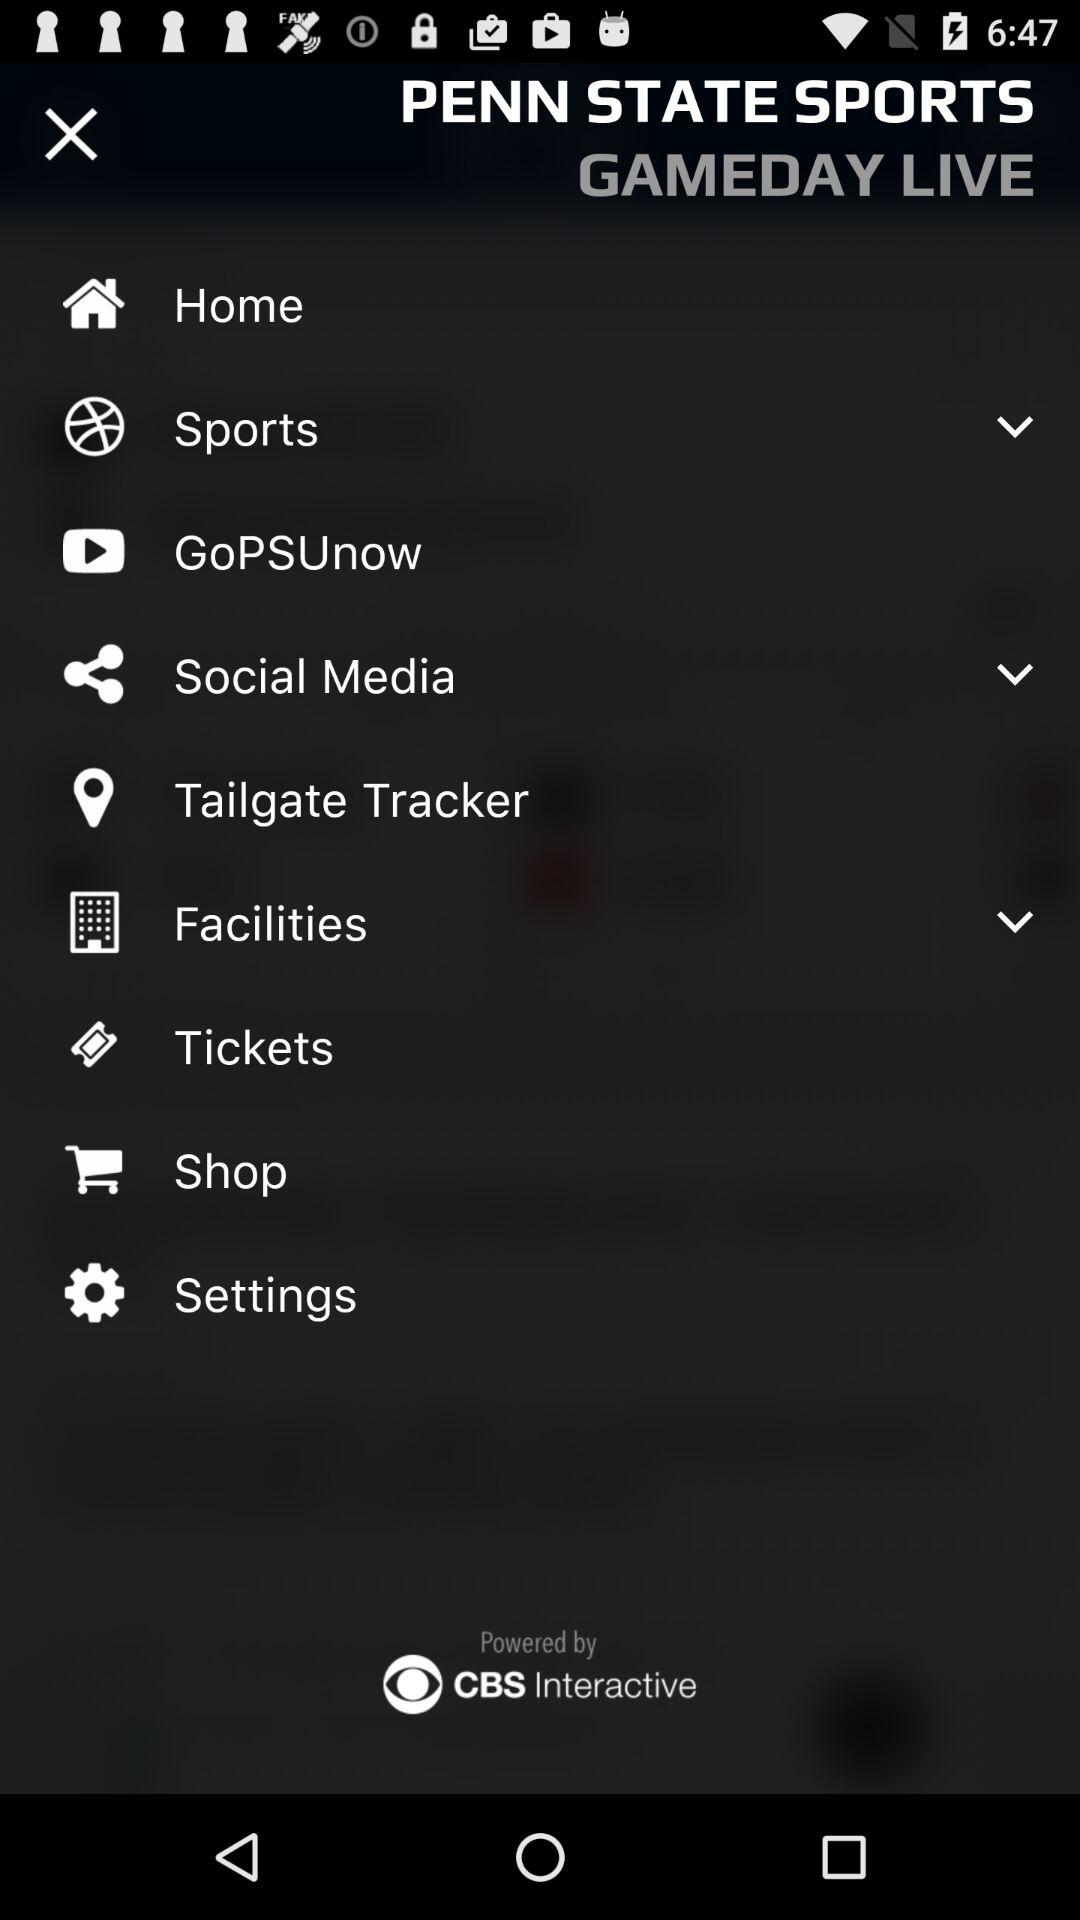This application is powered by whom? The application is powered by "CBS Interactive". 